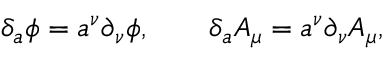<formula> <loc_0><loc_0><loc_500><loc_500>\delta _ { a } \phi = a ^ { \nu } \partial _ { \nu } \phi , \quad \delta _ { a } A _ { \mu } = a ^ { \nu } \partial _ { \nu } A _ { \mu } ,</formula> 